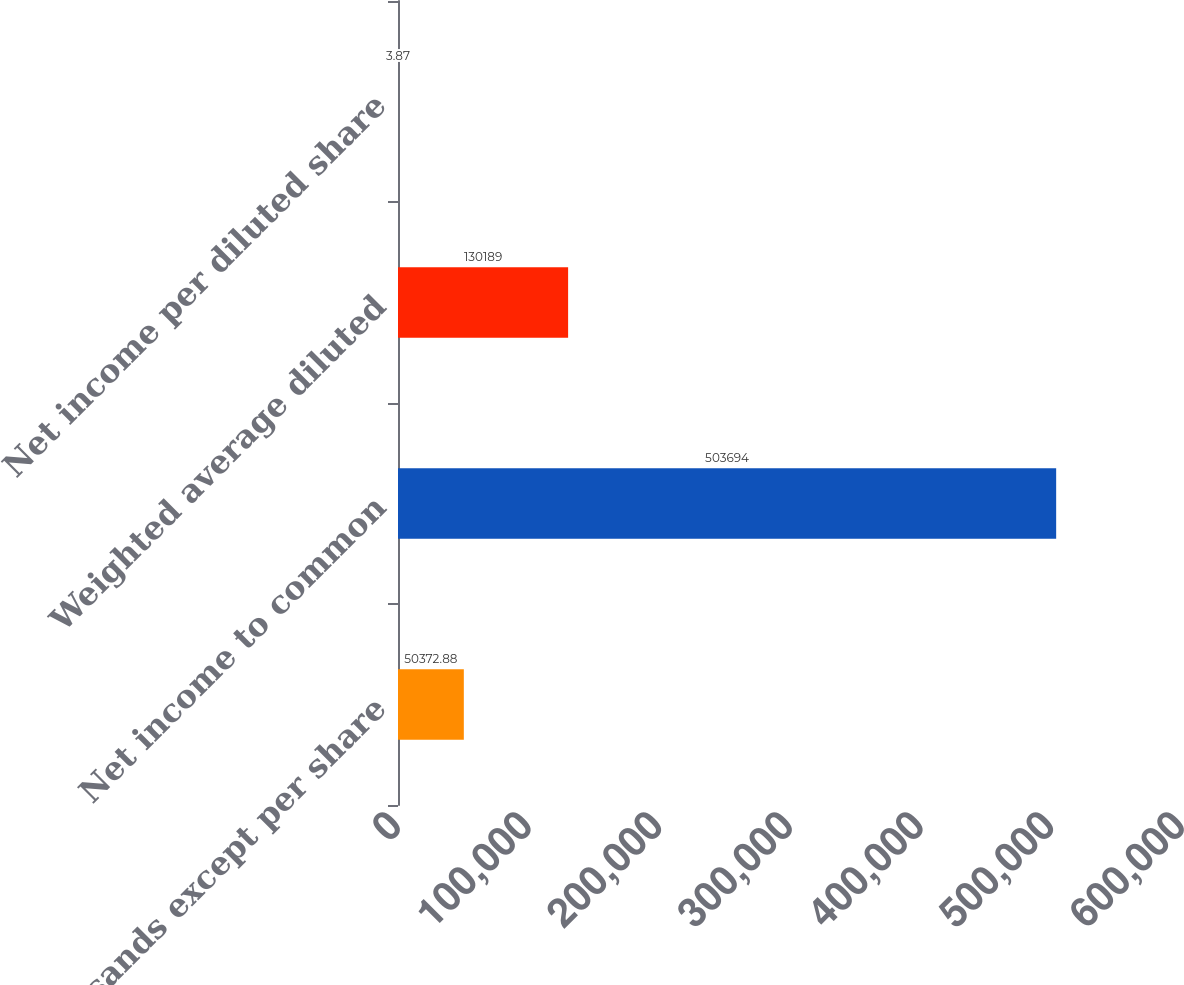<chart> <loc_0><loc_0><loc_500><loc_500><bar_chart><fcel>(In thousands except per share<fcel>Net income to common<fcel>Weighted average diluted<fcel>Net income per diluted share<nl><fcel>50372.9<fcel>503694<fcel>130189<fcel>3.87<nl></chart> 